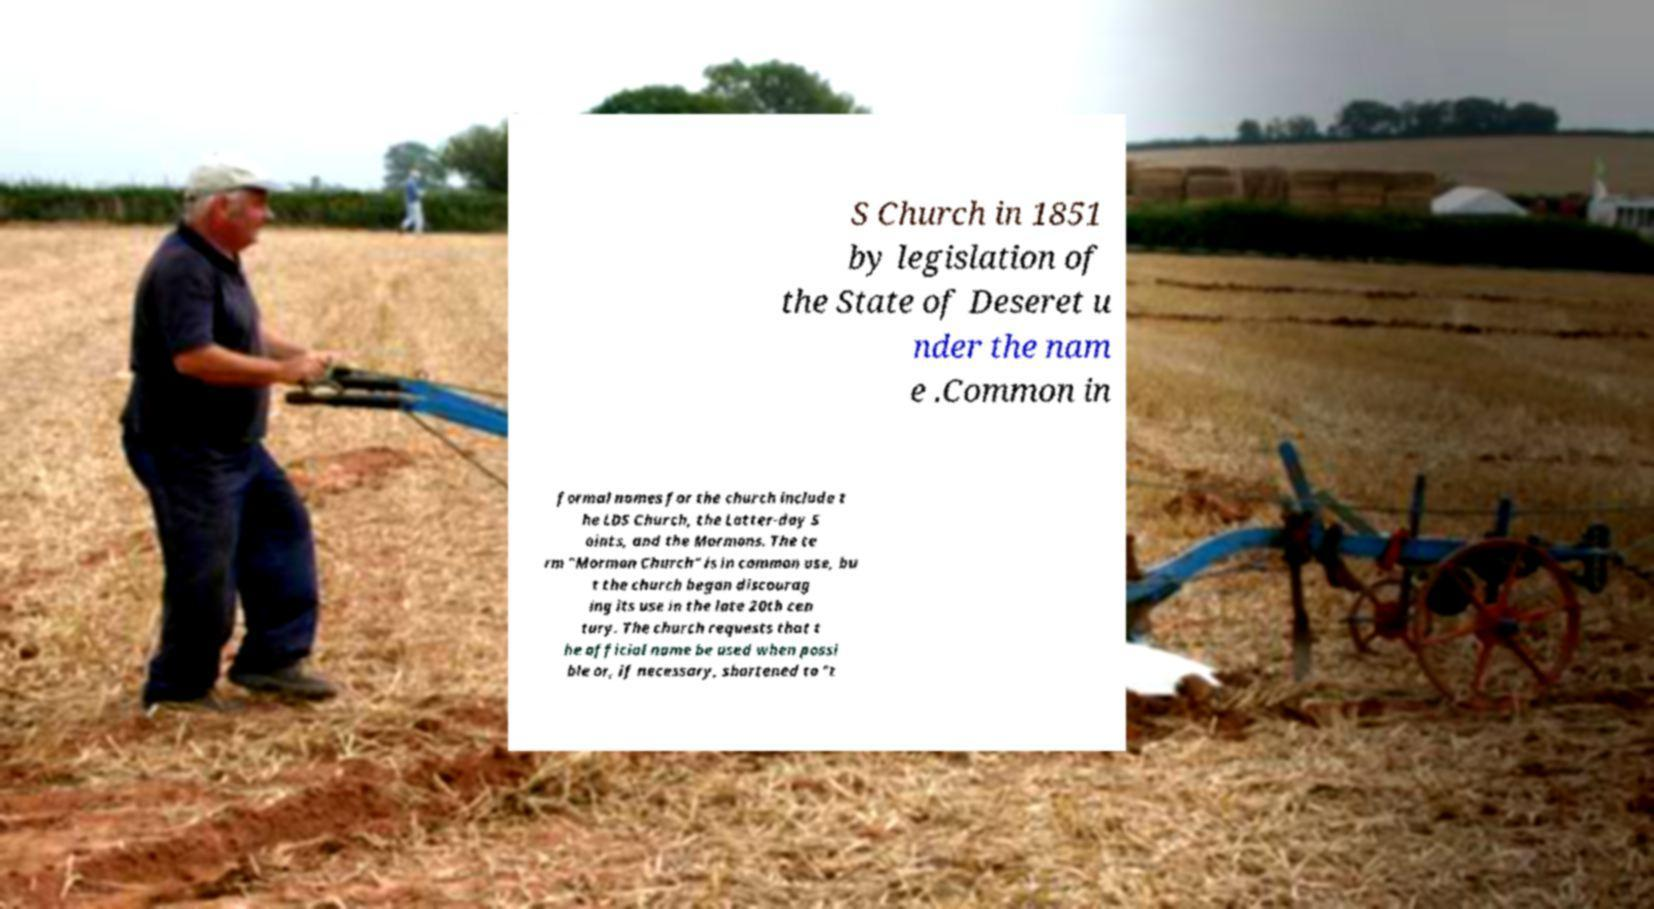Please read and relay the text visible in this image. What does it say? S Church in 1851 by legislation of the State of Deseret u nder the nam e .Common in formal names for the church include t he LDS Church, the Latter-day S aints, and the Mormons. The te rm "Mormon Church" is in common use, bu t the church began discourag ing its use in the late 20th cen tury. The church requests that t he official name be used when possi ble or, if necessary, shortened to "t 